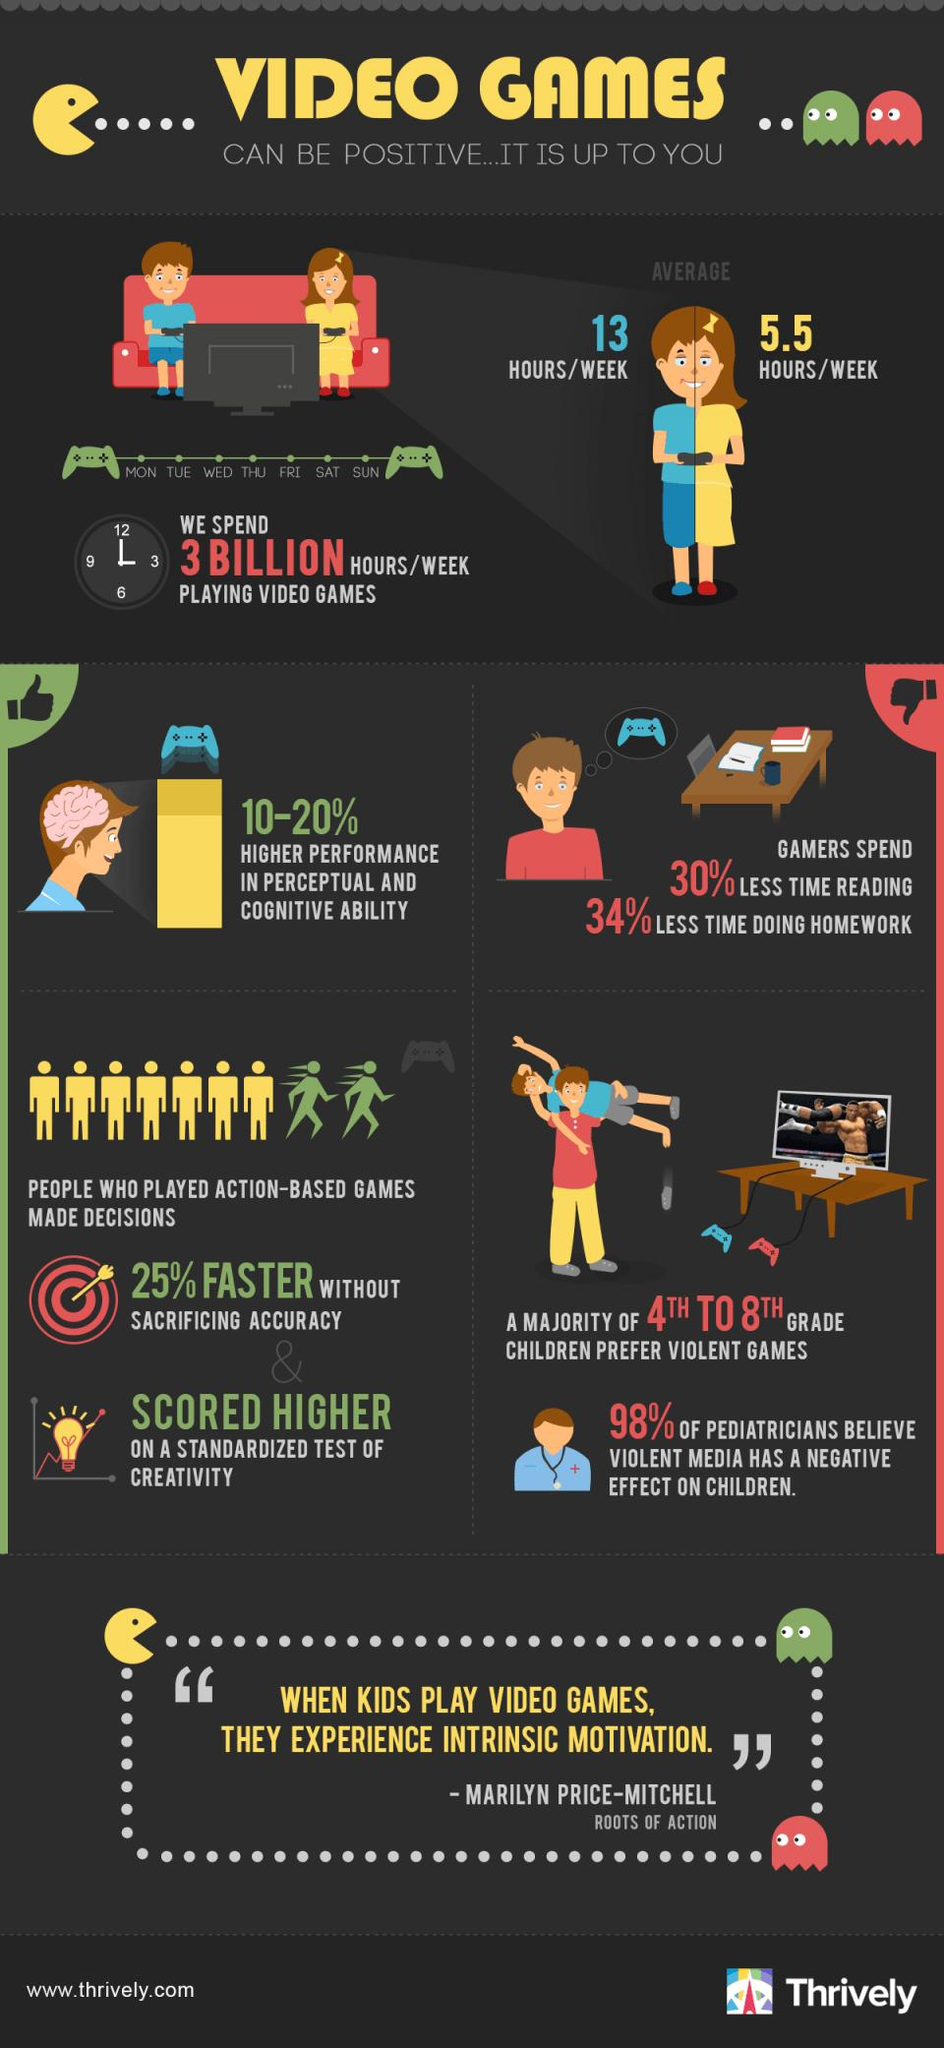Specify some key components in this picture. Individuals who regularly played action-based video games scored higher on standardized creativity tests compared to those who did not play such games. The average amount of time spent on video games by boys is 13 hours per week. The average amount of time spent on video games by girls is approximately 5.5 hours per week. According to pediatricians, violent media has a detrimental effect on children. Gamers showed significantly higher performance in perceptual and cognitive abilities, ranging from 10% to 20% compared to non-gamers. 